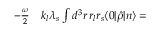<formula> <loc_0><loc_0><loc_500><loc_500>\begin{array} { r l } { - \frac { \omega } { 2 } } & k _ { l } \lambda _ { s } \int d ^ { 3 } r \, r _ { l } r _ { s } \langle 0 | \hat { \rho } | n \rangle = } \end{array}</formula> 